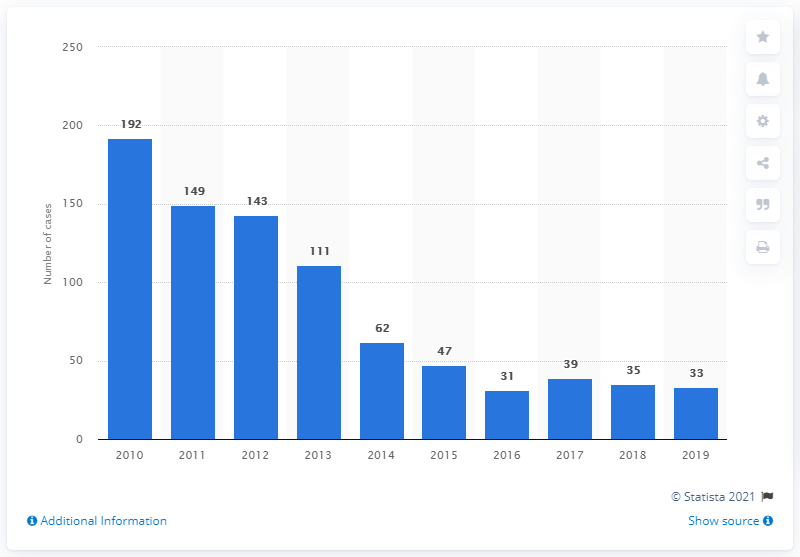How many malaria cases were reported in Singapore in 2019?
 33 